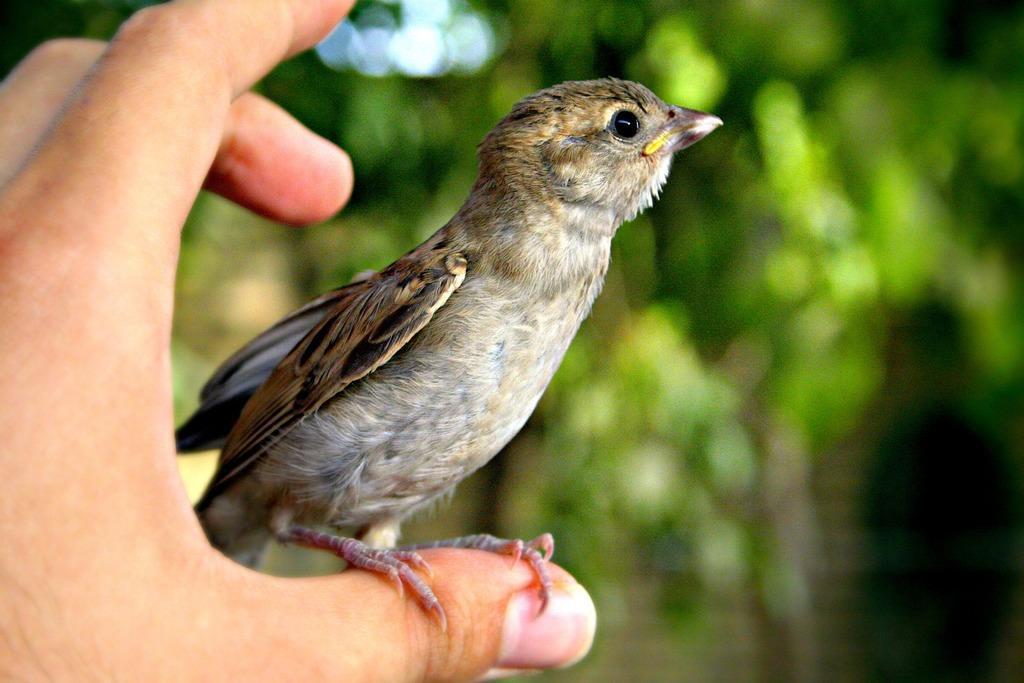In one or two sentences, can you explain what this image depicts? On the left corner of the picture, we see the hand of a human holding bird in his or her hand. There are trees in the background and it is blurred. 